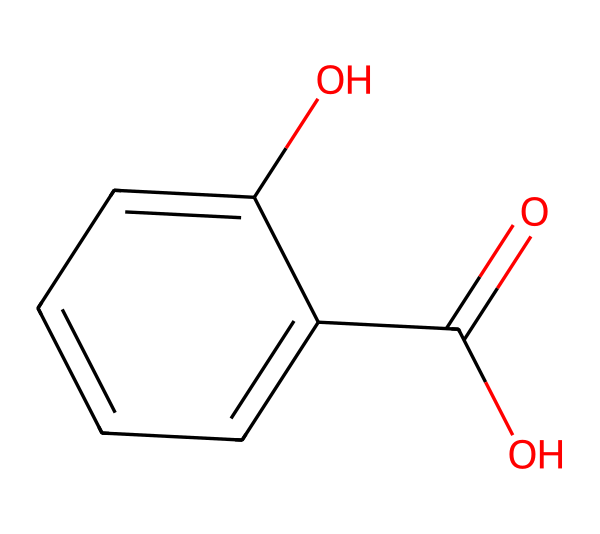What is the molecular formula of salicylic acid? The molecular formula can be determined by counting the number of carbon (C), hydrogen (H), and oxygen (O) atoms in the structure. The structure shows 7 carbon atoms, 6 hydrogen atoms, and 3 oxygen atoms. Thus, the molecular formula is C7H6O3.
Answer: C7H6O3 How many rings are present in salicylic acid? By examining the structure, we can see that it has one benzene ring, which consists of six carbon atoms arranged in a cyclic format. Therefore, there is one ring present in the structure.
Answer: 1 What functional groups are present in salicylic acid? Salicylic acid contains two functional groups: a carboxylic acid group (-COOH) and a hydroxyl group (-OH). The carboxylic acid is indicated by the -COOH and the hydroxyl is shown attached to the benzene ring.
Answer: carboxylic acid and hydroxyl Does salicylic acid have any chiral centers? A chiral center is typically a carbon atom bonded to four different groups. Analyzing the structure, all of its carbon atoms are either bonded to identical groups or are involved in the aromatic system, so there are no chiral centers.
Answer: no How does the presence of the hydroxyl group affect salicylic acid's solubility? The hydroxyl group (-OH) is hydrophilic, which increases salicylic acid's solubility in water. This is because it can form hydrogen bonds with water molecules, allowing it to dissolve better than non-polar substances.
Answer: increases solubility What effect does salicylic acid have on acne-prone skin? Salicylic acid is known for its exfoliating properties, which help to remove dead skin cells and unclog pores. This action reduces the formation of acne and improves overall skin texture.
Answer: reduces acne 